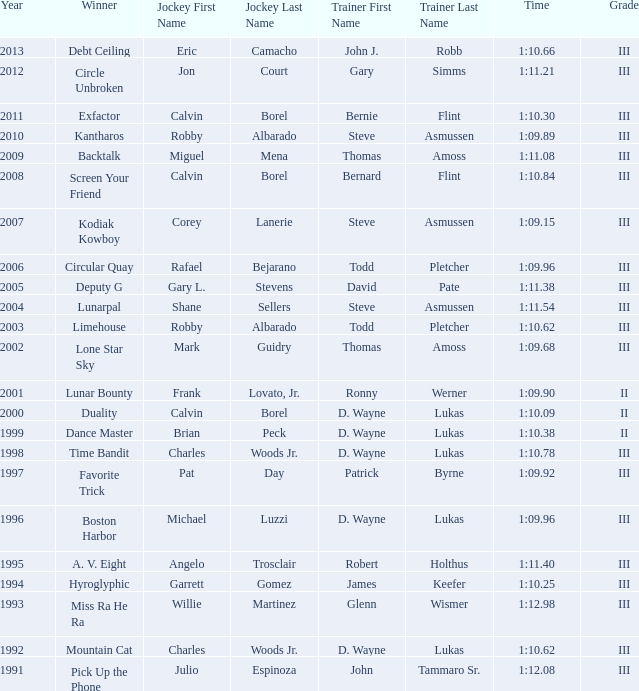What was the time for Screen Your Friend? 1:10.84. 